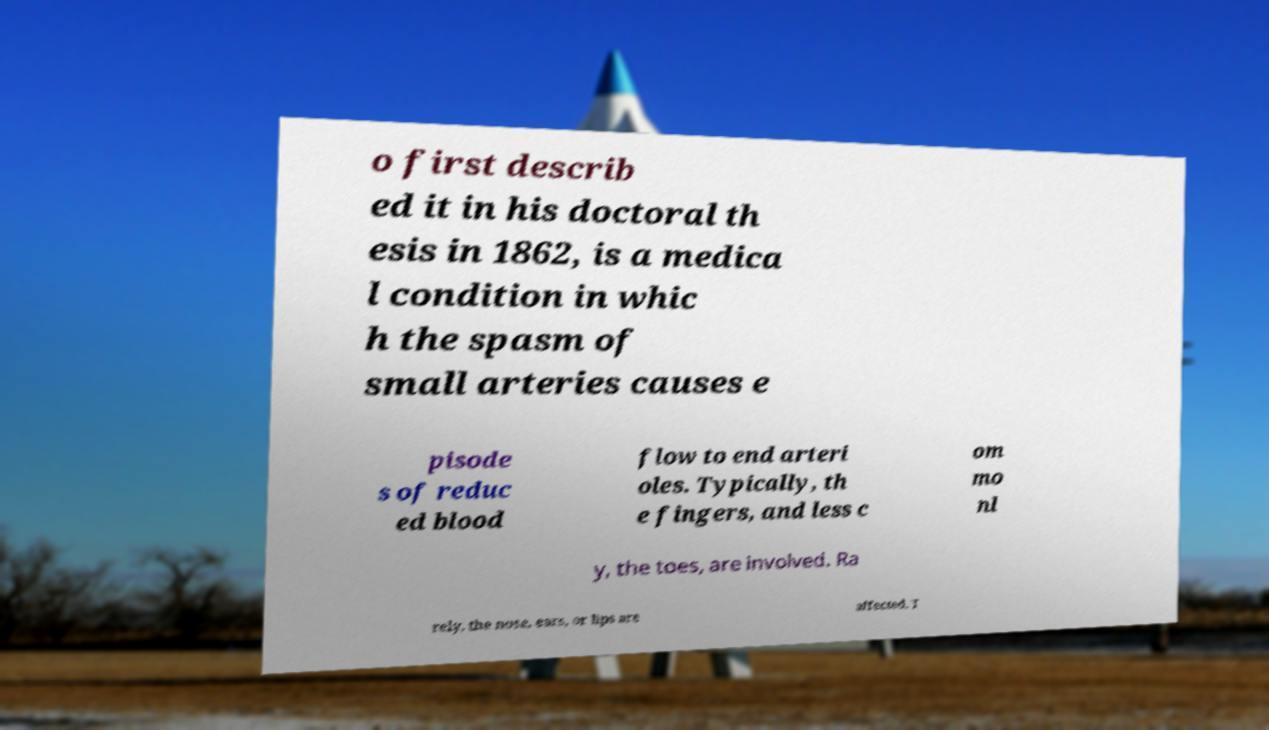Could you extract and type out the text from this image? o first describ ed it in his doctoral th esis in 1862, is a medica l condition in whic h the spasm of small arteries causes e pisode s of reduc ed blood flow to end arteri oles. Typically, th e fingers, and less c om mo nl y, the toes, are involved. Ra rely, the nose, ears, or lips are affected. T 